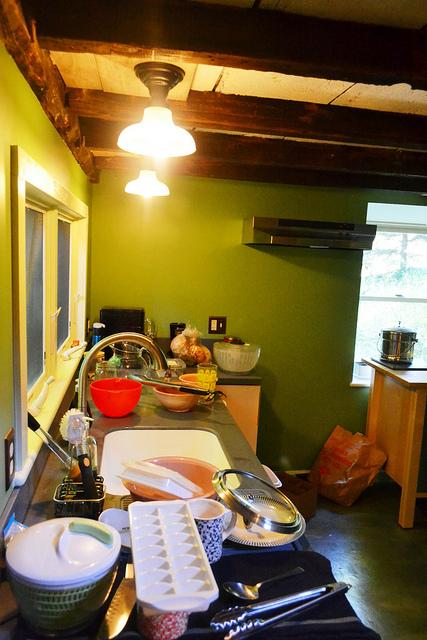What is the electrical device on the wall to the left of the window used for?

Choices:
A) hvac
B) entertainment
C) lighting
D) storage hvac 